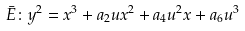Convert formula to latex. <formula><loc_0><loc_0><loc_500><loc_500>\bar { E } \colon y ^ { 2 } = x ^ { 3 } + a _ { 2 } u x ^ { 2 } + a _ { 4 } u ^ { 2 } x + a _ { 6 } u ^ { 3 }</formula> 